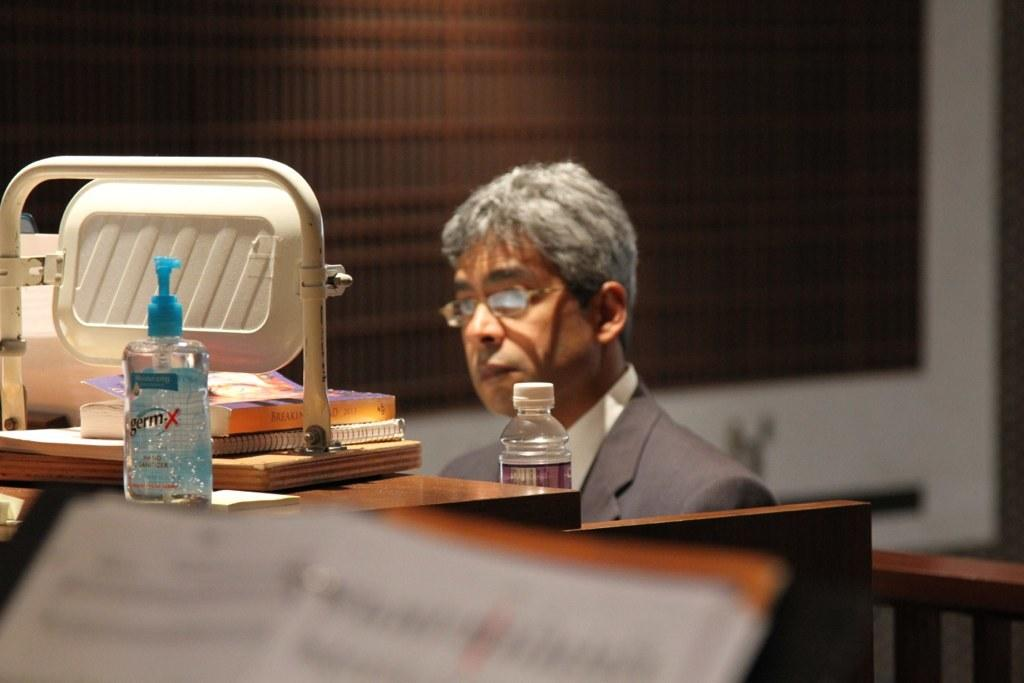<image>
Write a terse but informative summary of the picture. A man is sitting at a desk in front of a bottle of germ-x hand sanitizer 